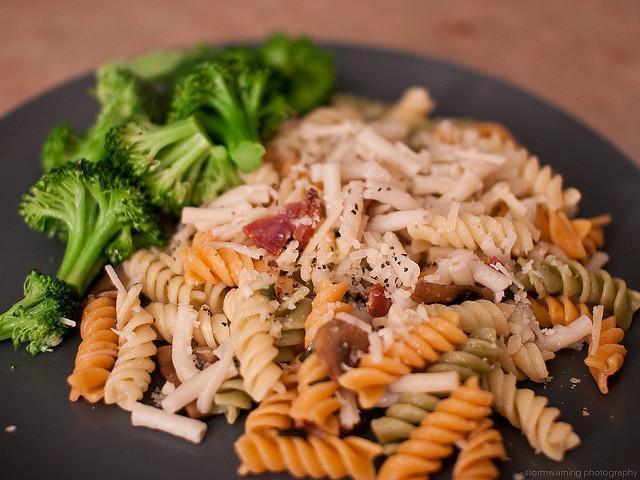What is next to the pasta?
Choose the correct response and explain in the format: 'Answer: answer
Rationale: rationale.'
Options: Apple, beef, lemon, broccoli. Answer: broccoli.
Rationale: There is a green vegetable, not meat or a fruit, next to the pasta. 